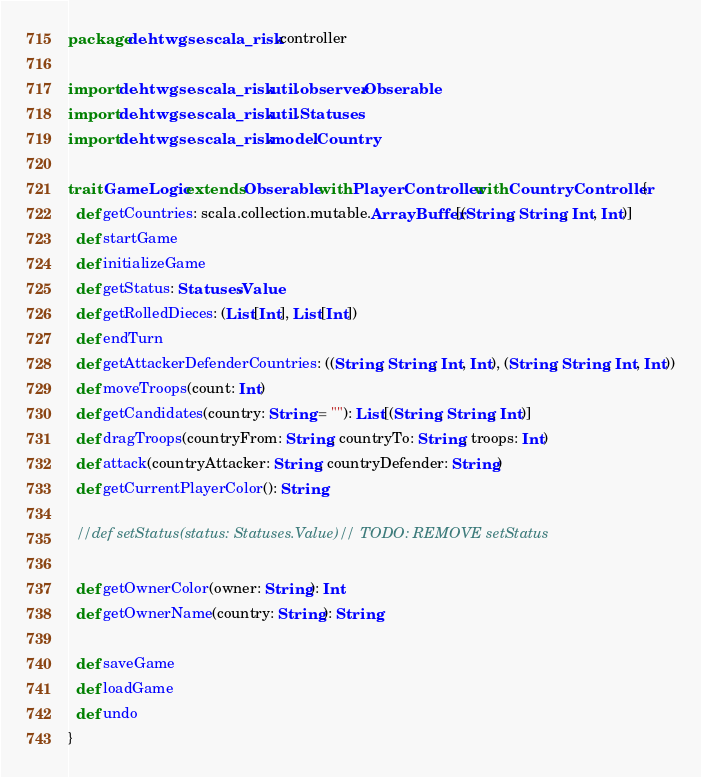Convert code to text. <code><loc_0><loc_0><loc_500><loc_500><_Scala_>package de.htwg.se.scala_risk.controller

import de.htwg.se.scala_risk.util.observer.Obserable
import de.htwg.se.scala_risk.util.Statuses
import de.htwg.se.scala_risk.model.Country

trait GameLogic extends Obserable with PlayerController with CountryController {
  def getCountries: scala.collection.mutable.ArrayBuffer[(String, String, Int, Int)]
  def startGame
  def initializeGame
  def getStatus: Statuses.Value
  def getRolledDieces: (List[Int], List[Int])
  def endTurn
  def getAttackerDefenderCountries: ((String, String, Int, Int), (String, String, Int, Int))
  def moveTroops(count: Int)
  def getCandidates(country: String = ""): List[(String, String, Int)]
  def dragTroops(countryFrom: String, countryTo: String, troops: Int)
  def attack(countryAttacker: String, countryDefender: String)
  def getCurrentPlayerColor(): String

  //def setStatus(status: Statuses.Value)// TODO: REMOVE setStatus

  def getOwnerColor(owner: String): Int
  def getOwnerName(country: String): String

  def saveGame
  def loadGame
  def undo
}
</code> 